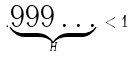<formula> <loc_0><loc_0><loc_500><loc_500>. \underset { H } { \underbrace { 9 9 9 \dots } } \, < 1</formula> 